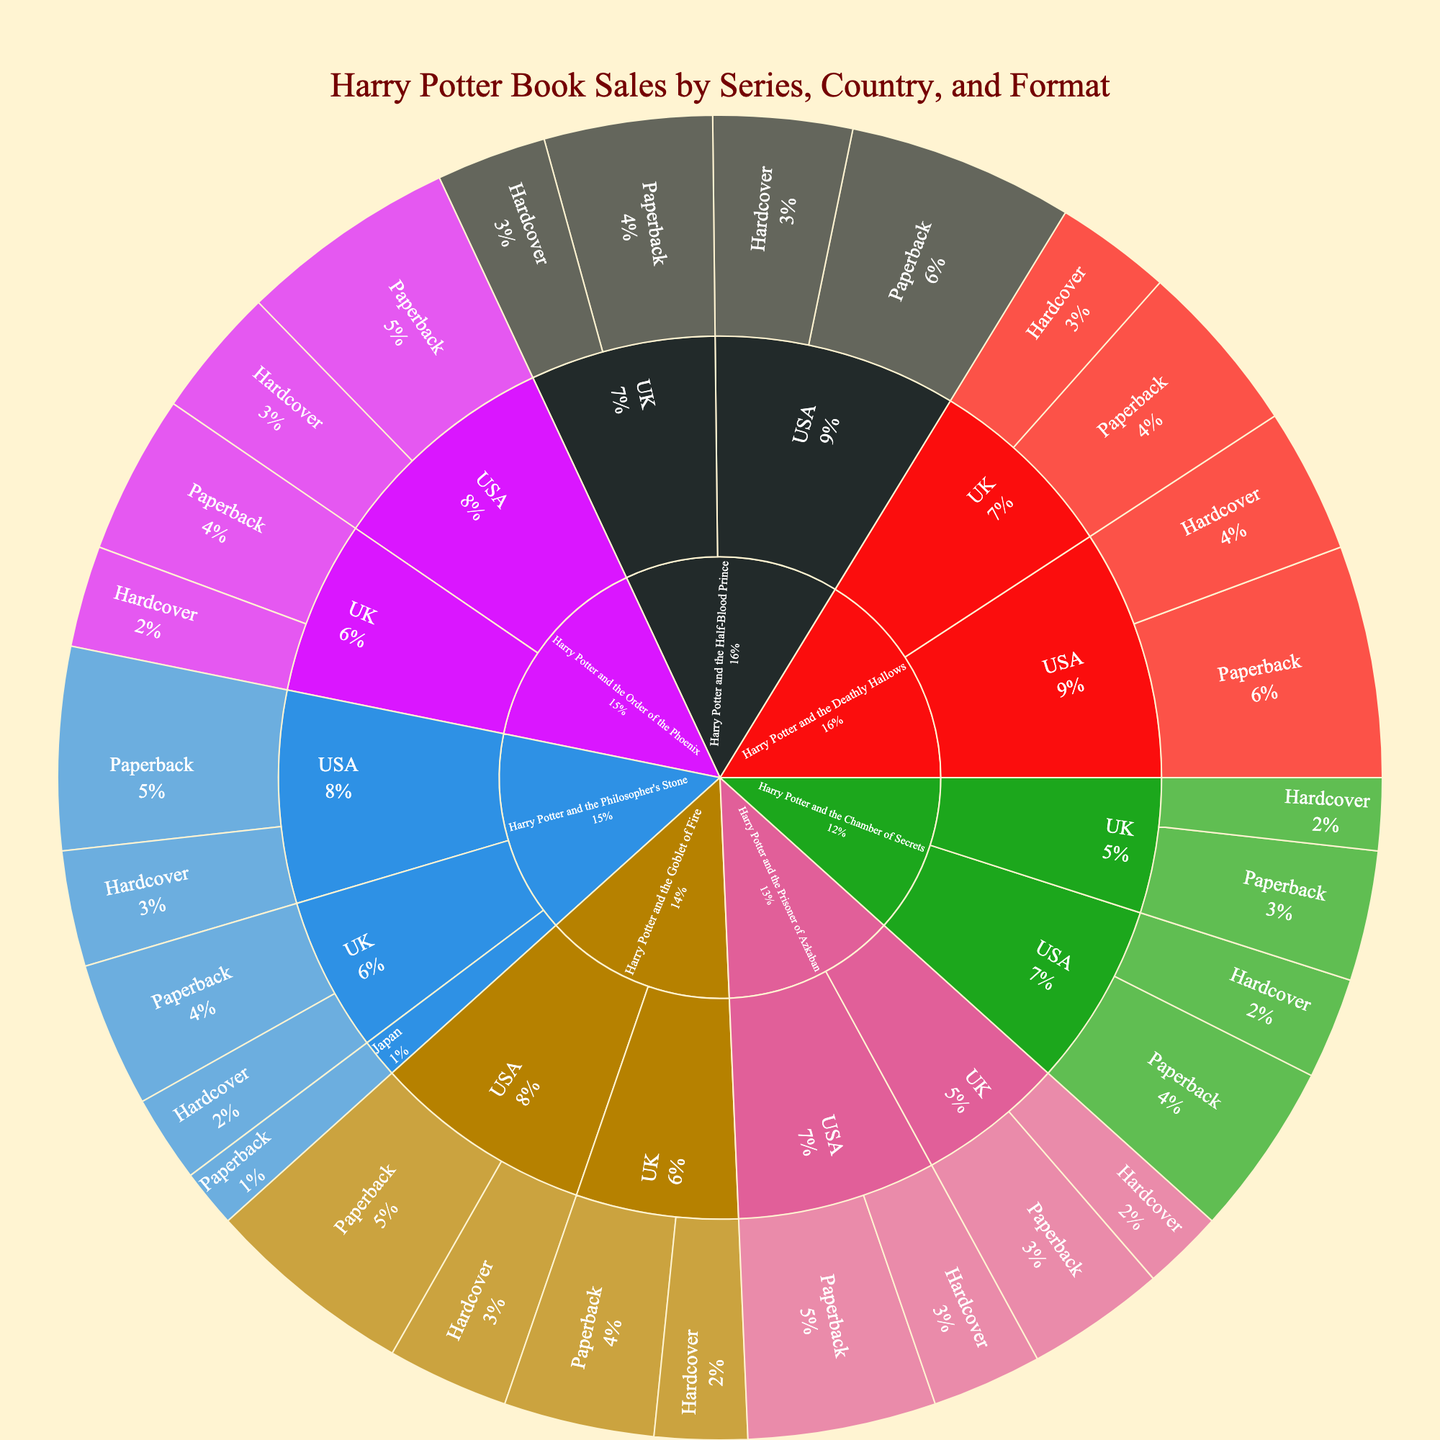What is the title of the plot? The title is placed prominently at the top of the plot and provides an overall idea of what the plot is about.
Answer: Harry Potter Book Sales by Series, Country, and Format How many series are represented in the plot? By examining the outermost segments of the sunburst plot, each labeled with a different book title, we can count the unique series.
Answer: 7 Which series has the highest sales? By visually comparing the arcade size corresponding to each series on the sunburst plot, the one with the largest area represents the highest sales.
Answer: Harry Potter and the Philosopher's Stone How do the USA sales of "Harry Potter and the Goblet of Fire" compare between Hardcover and Paperback formats? By finding the segments for "Harry Potter and the Goblet of Fire" within the USA section, we can visually compare their sizes. Paperback appears larger, indicating higher sales.
Answer: Paperback sales are higher What are the total sales of "Harry Potter and the Half-Blood Prince" in the UK? Sum up the sales from the UK segments of "Harry Potter and the Half-Blood Prince" for both Hardcover and Paperback formats.
Answer: 9,600,000 Which country has more sales for "Harry Potter and the Chamber of Secrets," the UK or the USA? Identify and compare the total sales from the UK and USA segments for "Harry Potter and the Chamber of Secrets." USA segments appear significantly larger.
Answer: USA What is the ratio of Hardcover to Paperback sales for "Harry Potter and the Order of the Phoenix" in the UK? Divide the Hardcover sales by the Paperback sales within the UK segment of "Harry Potter and the Order of the Phoenix" to find the ratio. The Hardcover sales are 3,500,000 and Paperback are 5,500,000.
Answer: 0.64 Which series has the lowest sales in Japan? By focusing on the Japan segments of the sunburst plot, only "Harry Potter and the Philosopher's Stone" is present. Hence, it must be the lowest.
Answer: Harry Potter and the Philosopher's Stone Among all series, which format has the highest total sales? We need to compare the summations of the areas representing Hardcover and Paperback sales across all series. Visually, Paperback formats across all series appear to have consistently higher sales.
Answer: Paperback How do the UK sales of "Harry Potter and the Prisoner of Azkaban" compare between Hardcover and Paperback formats? Visually inspect the segments of the UK sales for "Harry Potter and the Prisoner of Azkaban" and compare their sizes. Paperback seems to have larger sections, indicating higher sales.
Answer: Paperback sales are higher 